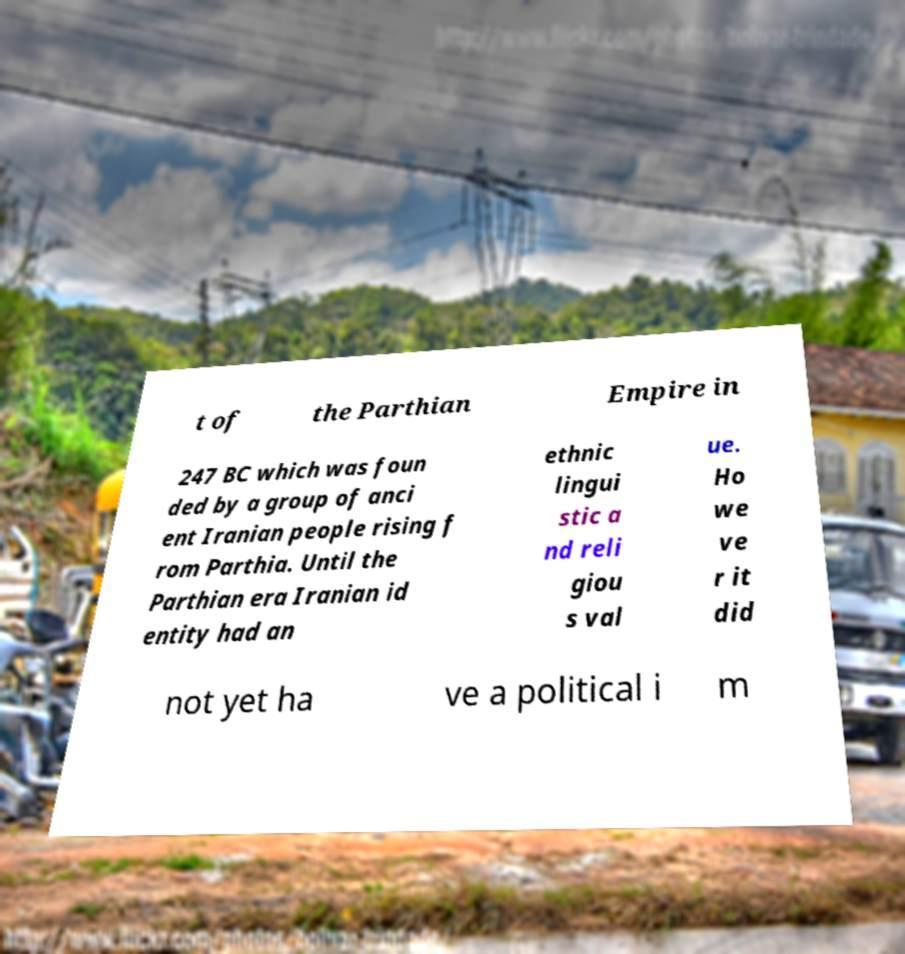For documentation purposes, I need the text within this image transcribed. Could you provide that? t of the Parthian Empire in 247 BC which was foun ded by a group of anci ent Iranian people rising f rom Parthia. Until the Parthian era Iranian id entity had an ethnic lingui stic a nd reli giou s val ue. Ho we ve r it did not yet ha ve a political i m 